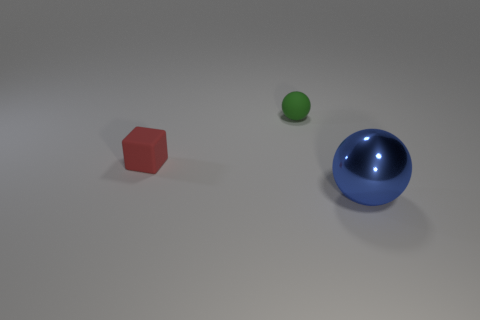What color is the matte block that is the same size as the green rubber object?
Offer a very short reply. Red. How big is the red object?
Your answer should be compact. Small. Does the object behind the block have the same material as the red object?
Ensure brevity in your answer.  Yes. Is the shape of the red rubber thing the same as the metallic thing?
Offer a very short reply. No. There is a tiny object behind the object that is left of the tiny rubber thing that is on the right side of the red thing; what is its shape?
Offer a very short reply. Sphere. Does the matte object in front of the small green rubber thing have the same shape as the thing to the right of the small green sphere?
Make the answer very short. No. Are there any red cubes made of the same material as the tiny green object?
Ensure brevity in your answer.  Yes. What is the color of the sphere on the left side of the thing that is to the right of the ball to the left of the large blue object?
Make the answer very short. Green. Are the sphere on the left side of the large blue thing and the ball that is in front of the matte block made of the same material?
Your answer should be compact. No. What shape is the small object that is in front of the matte sphere?
Provide a succinct answer. Cube. 